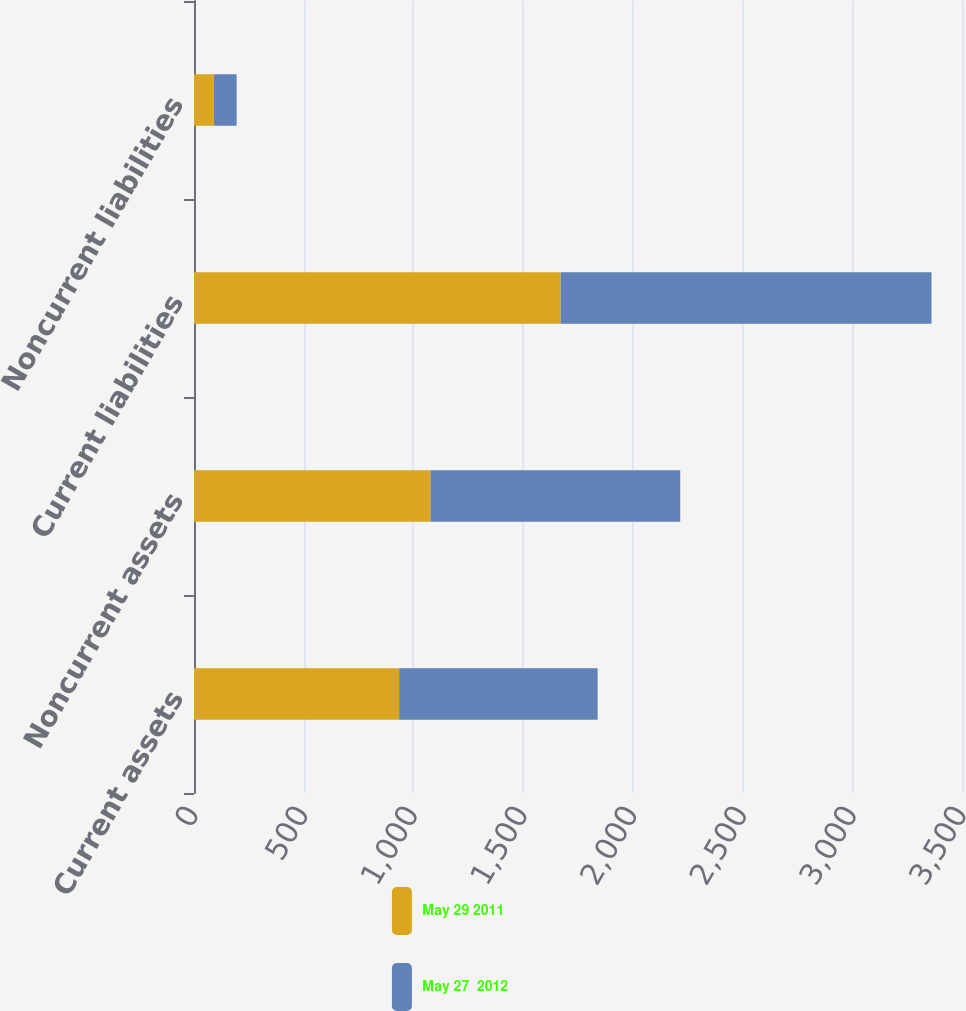Convert chart to OTSL. <chart><loc_0><loc_0><loc_500><loc_500><stacked_bar_chart><ecel><fcel>Current assets<fcel>Noncurrent assets<fcel>Current liabilities<fcel>Noncurrent liabilities<nl><fcel>May 29 2011<fcel>934.8<fcel>1078<fcel>1671<fcel>91<nl><fcel>May 27  2012<fcel>904.7<fcel>1138<fcel>1690.1<fcel>103.3<nl></chart> 